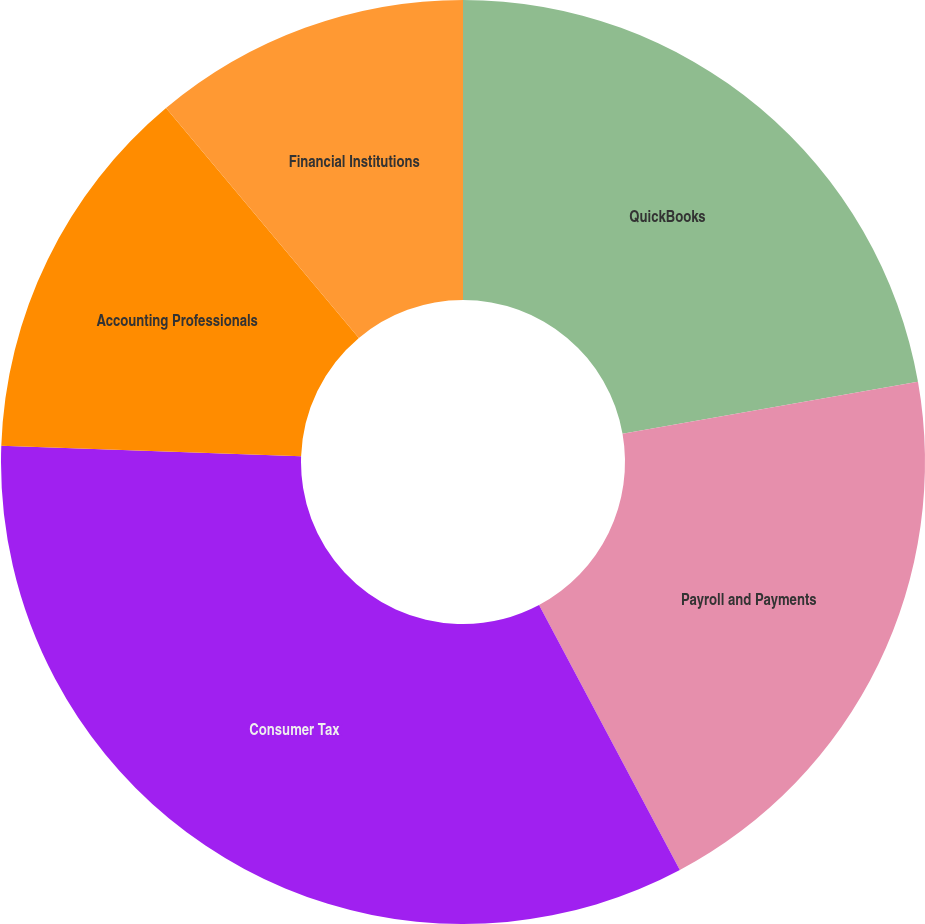Convert chart to OTSL. <chart><loc_0><loc_0><loc_500><loc_500><pie_chart><fcel>QuickBooks<fcel>Payroll and Payments<fcel>Consumer Tax<fcel>Accounting Professionals<fcel>Financial Institutions<nl><fcel>22.22%<fcel>20.0%<fcel>33.33%<fcel>13.33%<fcel>11.11%<nl></chart> 